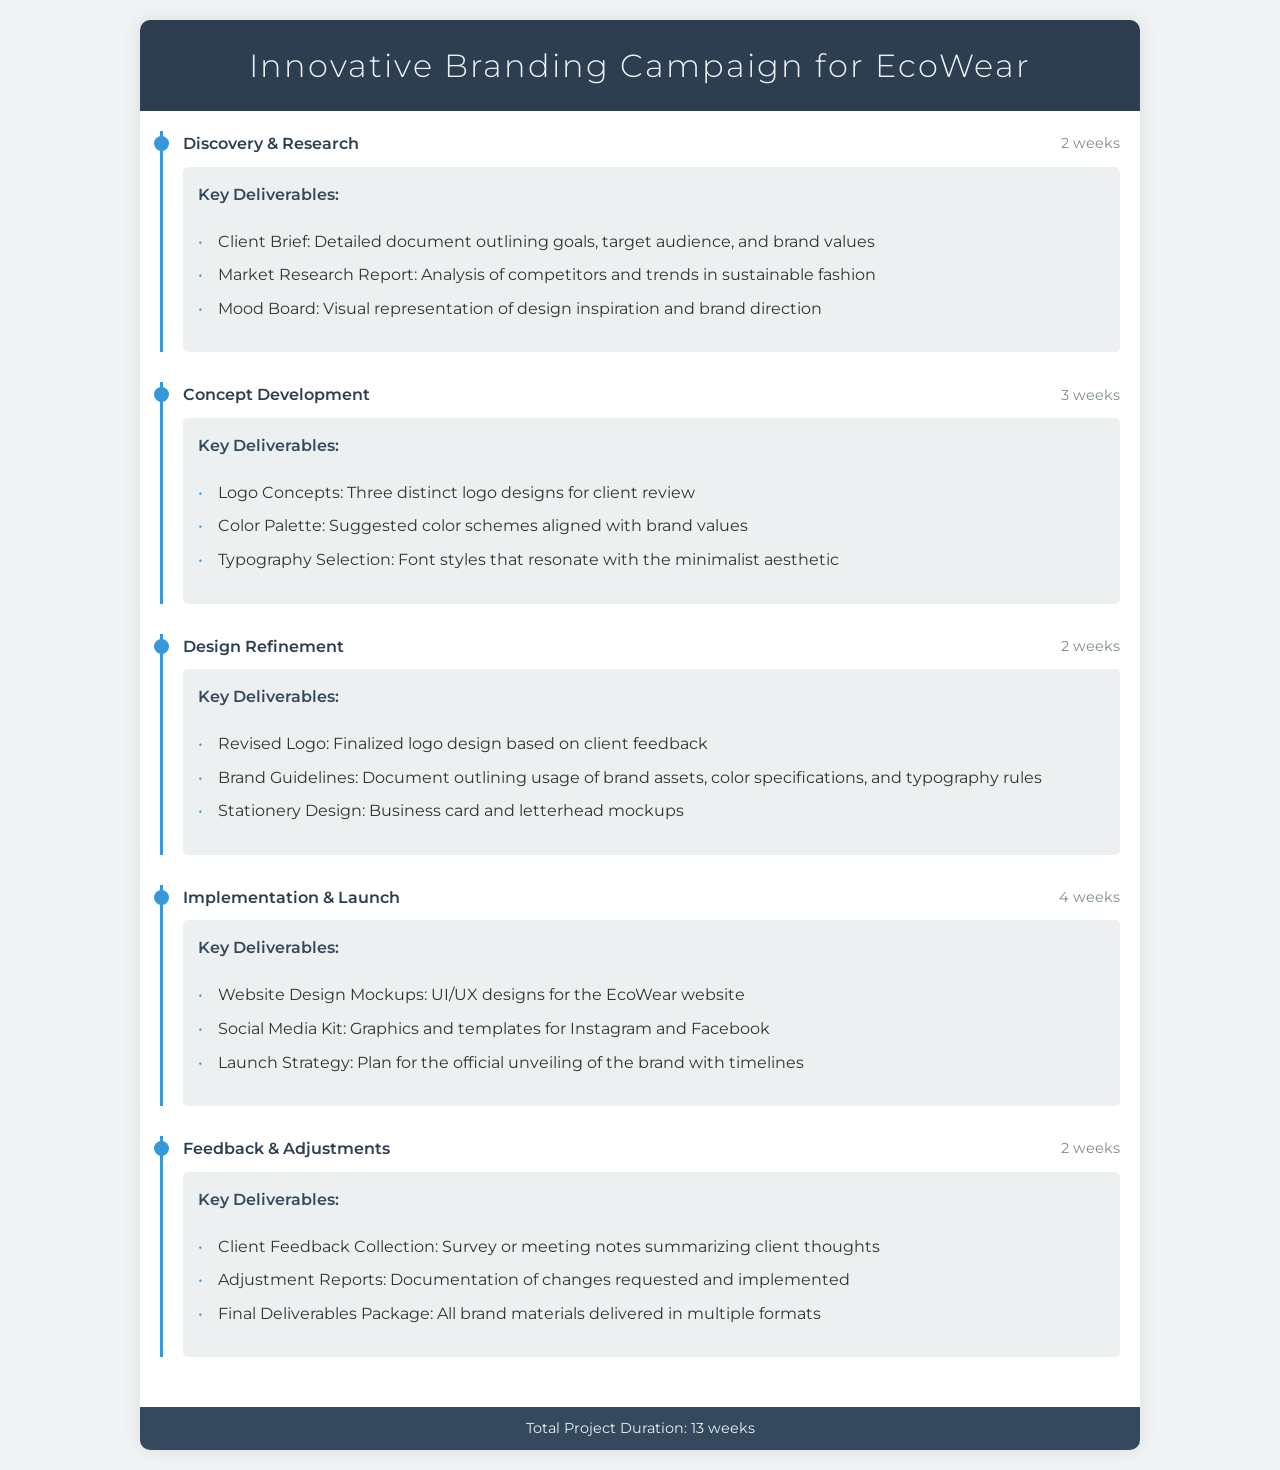What is the total project duration? The total project duration is specified in the footer of the document, summarizing the entire timeline for the branding campaign.
Answer: 13 weeks How long is the Concept Development phase? The duration of the Concept Development phase is listed alongside its title in the document.
Answer: 3 weeks What are the key deliverables in the Design Refinement phase? The document outlines the major deliverables as bullet points within the Design Refinement phase section.
Answer: Revised Logo, Brand Guidelines, Stationery Design Which phase comes after Implementation & Launch? To determine the order of phases, one can look at the layout and sequence presented in the document.
Answer: Feedback & Adjustments What type of research is included in the Discovery & Research phase? The document details the specific types of research and documents that are to be delivered in the Discovery & Research phase.
Answer: Market Research Report How many logo concepts will be developed? The number of logo concepts is specified in the deliverables of the Concept Development phase.
Answer: Three distinct logo designs What is the color scheme referenced in the Concept Development phase? The specifics of the color scheme can be found listed under the deliverables of the Concept Development phase.
Answer: Suggested color schemes aligned with brand values What is included in the Launch Strategy deliverable? To identify what is covered in the Launch Strategy, one must refer to the Implementation & Launch phase deliverables.
Answer: Plan for the official unveiling of the brand with timelines 